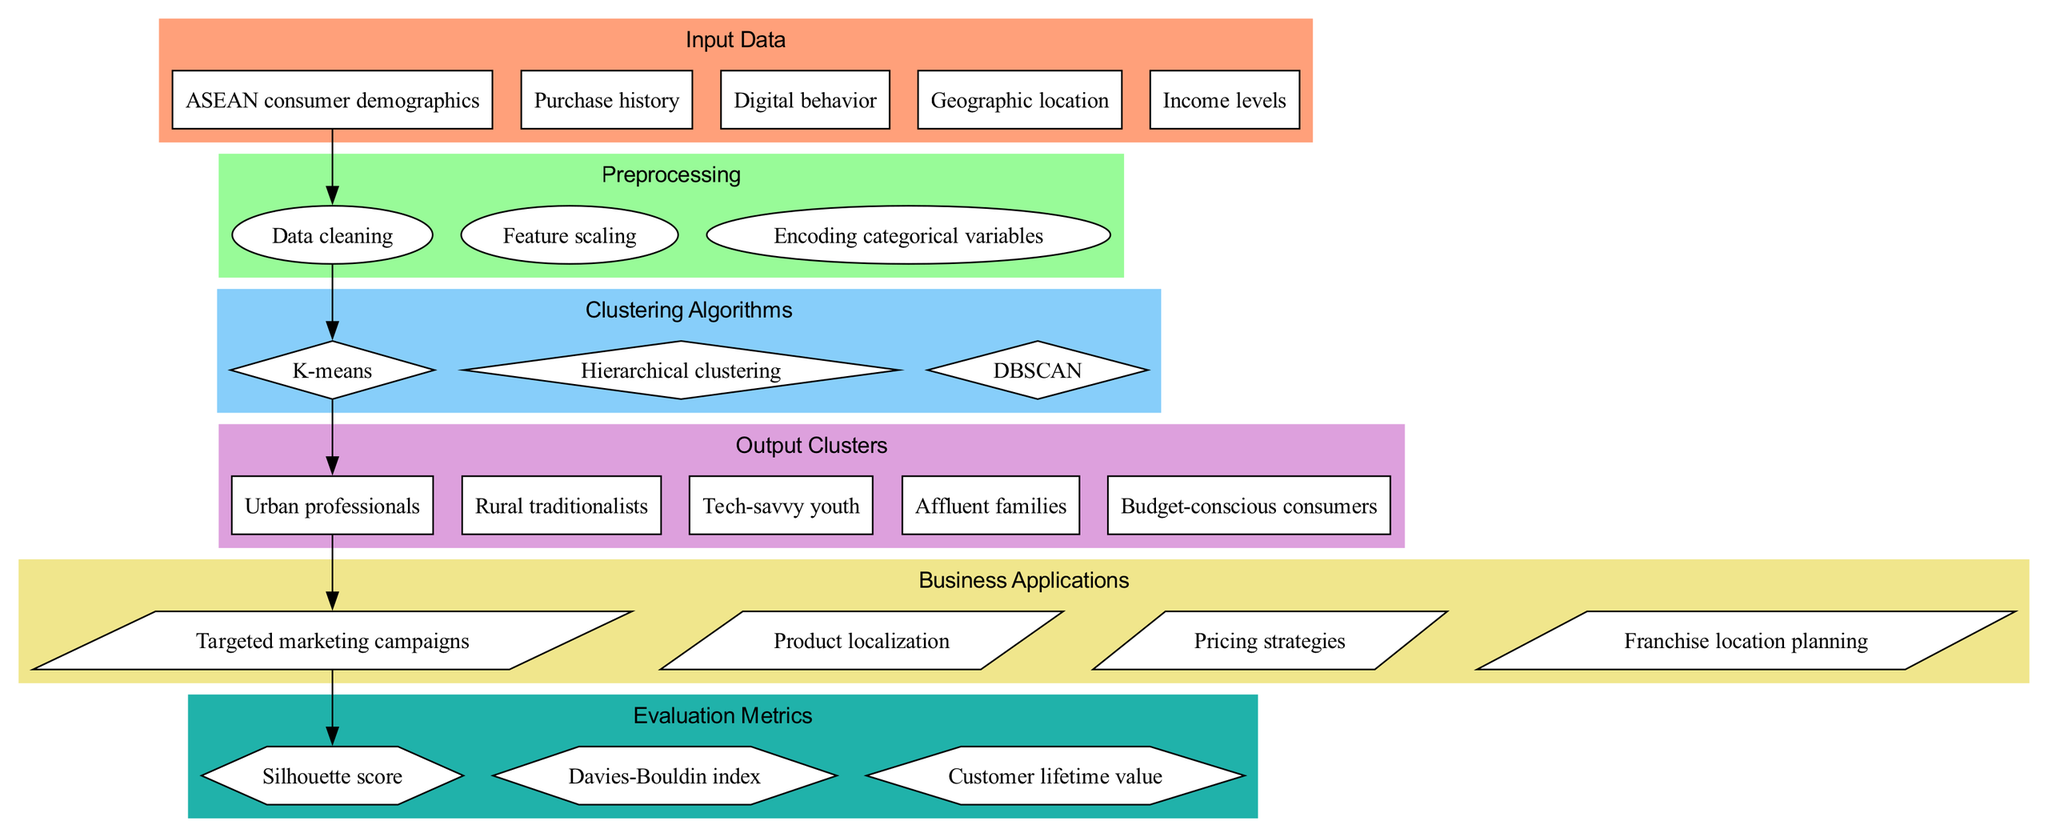What are the input data types used in this model? The diagram lists five input data types: ASEAN consumer demographics, Purchase history, Digital behavior, Geographic location, and Income levels. These elements are grouped together in the "Input Data" section.
Answer: ASEAN consumer demographics, Purchase history, Digital behavior, Geographic location, Income levels How many clustering algorithms are represented in the diagram? The diagram shows three clustering algorithms: K-means, Hierarchical clustering, and DBSCAN, which are found in the "Clustering Algorithms" section.
Answer: 3 Which output cluster is associated with targeted marketing campaigns? Following the flow in the diagram, the output cluster associated with targeted marketing campaigns is "Urban professionals," as indicated by the directed edge from "Urban professionals" to "Targeted marketing campaigns."
Answer: Urban professionals What preprocessing step comes after data cleaning? According to the diagram, the step that follows "Data cleaning" is "Feature scaling." This can be traced through the arrows connecting the nodes.
Answer: Feature scaling How many business applications are outlined in the diagram? The diagram specifies four business applications: Targeted marketing campaigns, Product localization, Pricing strategies, and Franchise location planning, which are situated in the "Business Applications" section.
Answer: 4 Which evaluation metric is directly connected to targeted marketing campaigns? The diagram illustrates that "Targeted marketing campaigns" lead to the evaluation metric "Silhouette score," as it shows a direct connection through an arrow, indicating a flow of information.
Answer: Silhouette score What is the relationship between K-means and Urban professionals? The diagram indicates a direct relationship where K-means leads to the output cluster "Urban professionals." This flow is depicted by the directed edge connecting the two nodes.
Answer: K-means leads to Urban professionals What is the purpose of the DBSCAN algorithm in this model? The diagram does not specify a direct purpose for DBSCAN. However, as a clustering algorithm, it serves to group data based on density. Its inclusion in the diagram implies its usage in analyzing the input data.
Answer: Grouping data based on density 